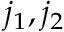<formula> <loc_0><loc_0><loc_500><loc_500>j _ { 1 } , j _ { 2 }</formula> 